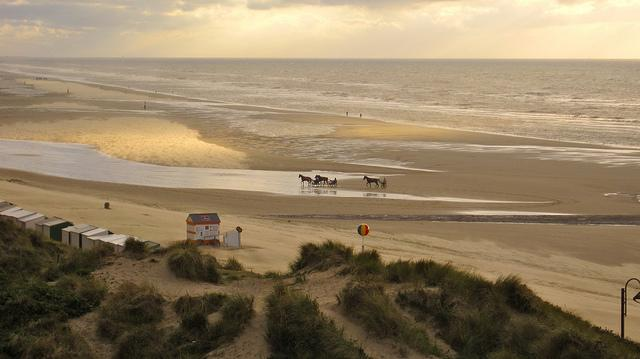What are the horses doing? walking 